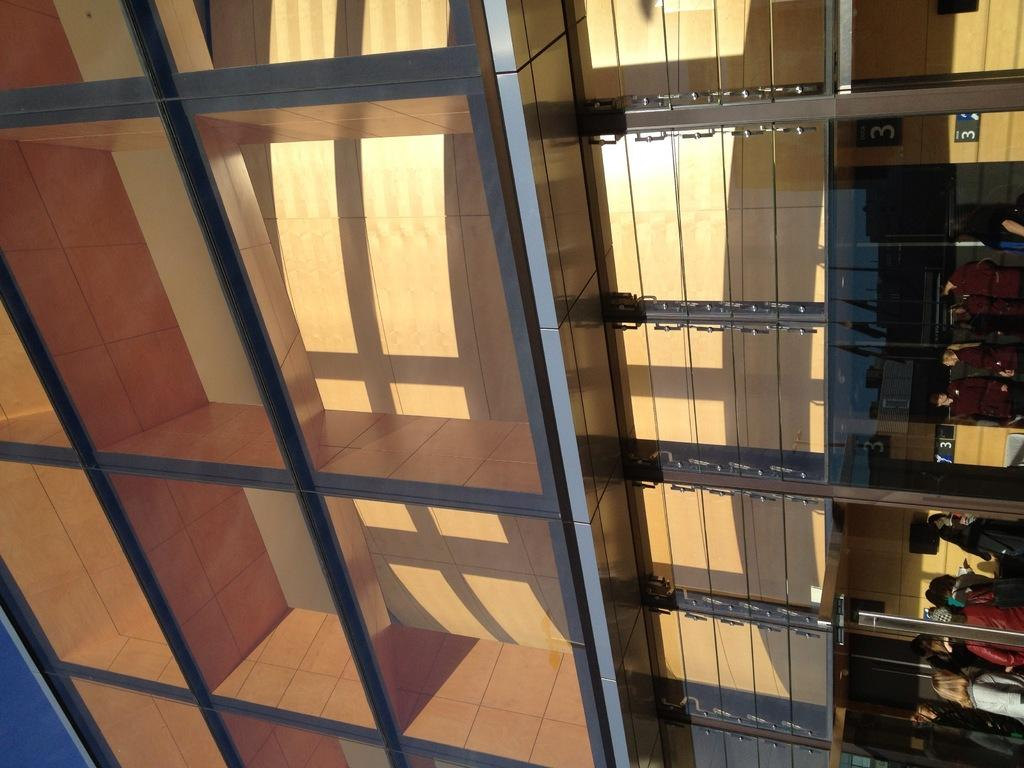<image>
Present a compact description of the photo's key features. some people behind a large structure with the number 3 on the wall on the right hand side of the image 